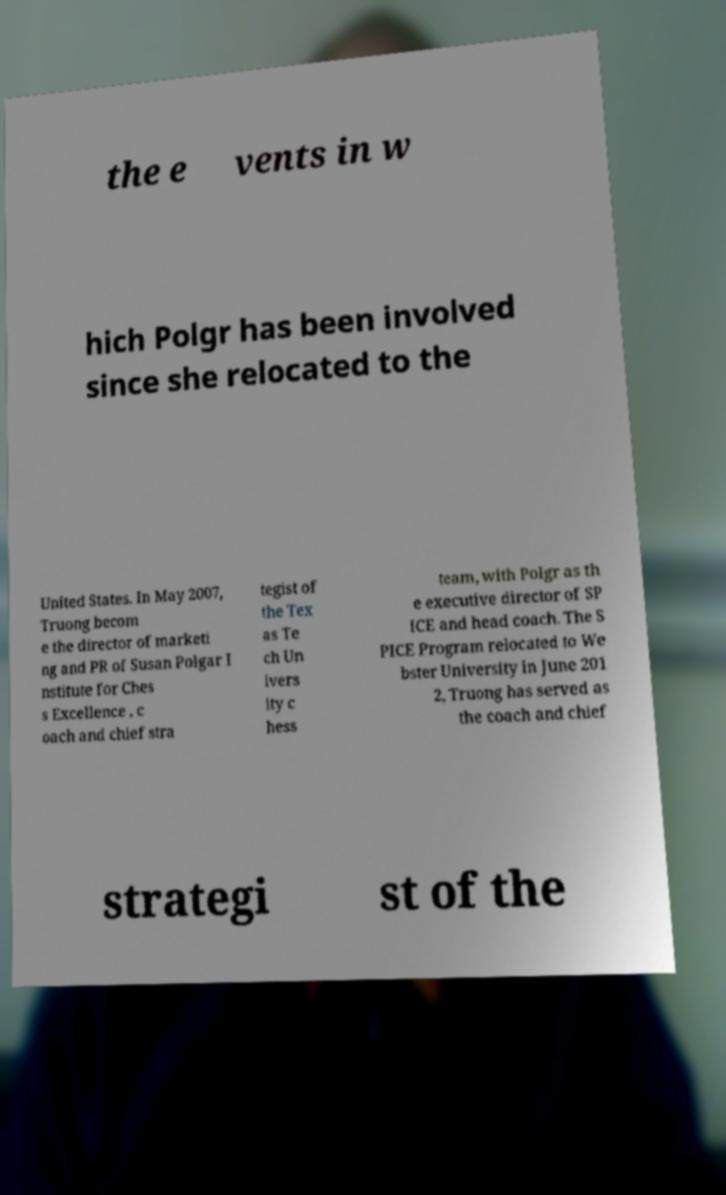There's text embedded in this image that I need extracted. Can you transcribe it verbatim? the e vents in w hich Polgr has been involved since she relocated to the United States. In May 2007, Truong becom e the director of marketi ng and PR of Susan Polgar I nstitute for Ches s Excellence , c oach and chief stra tegist of the Tex as Te ch Un ivers ity c hess team, with Polgr as th e executive director of SP ICE and head coach. The S PICE Program relocated to We bster University in June 201 2, Truong has served as the coach and chief strategi st of the 